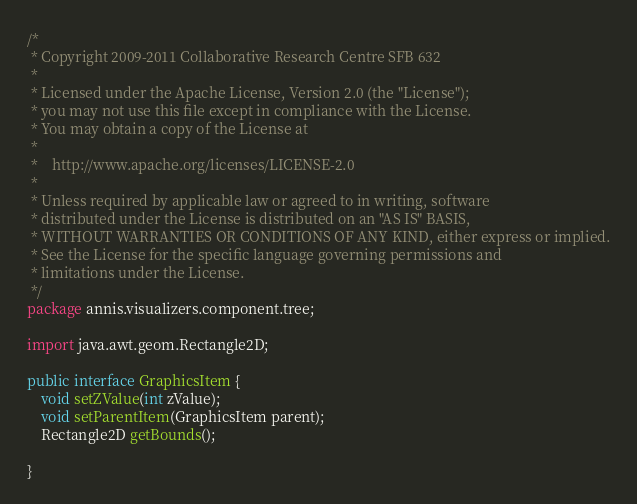Convert code to text. <code><loc_0><loc_0><loc_500><loc_500><_Java_>/*
 * Copyright 2009-2011 Collaborative Research Centre SFB 632 
 *
 * Licensed under the Apache License, Version 2.0 (the "License");
 * you may not use this file except in compliance with the License.
 * You may obtain a copy of the License at
 *
 *    http://www.apache.org/licenses/LICENSE-2.0
 *
 * Unless required by applicable law or agreed to in writing, software
 * distributed under the License is distributed on an "AS IS" BASIS,
 * WITHOUT WARRANTIES OR CONDITIONS OF ANY KIND, either express or implied.
 * See the License for the specific language governing permissions and
 * limitations under the License.
 */
package annis.visualizers.component.tree;

import java.awt.geom.Rectangle2D;

public interface GraphicsItem {
	void setZValue(int zValue);
	void setParentItem(GraphicsItem parent);
	Rectangle2D getBounds();
	
}</code> 